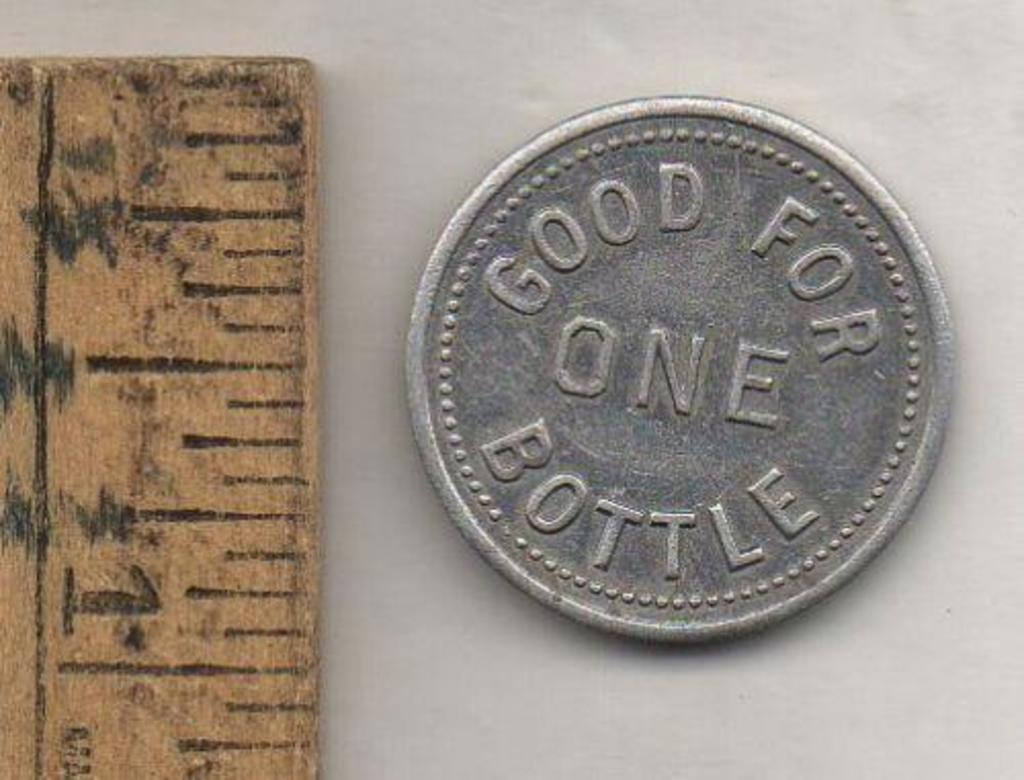<image>
Share a concise interpretation of the image provided. A coin that can be traded for one bottle measures at just under an inch in diameter. 